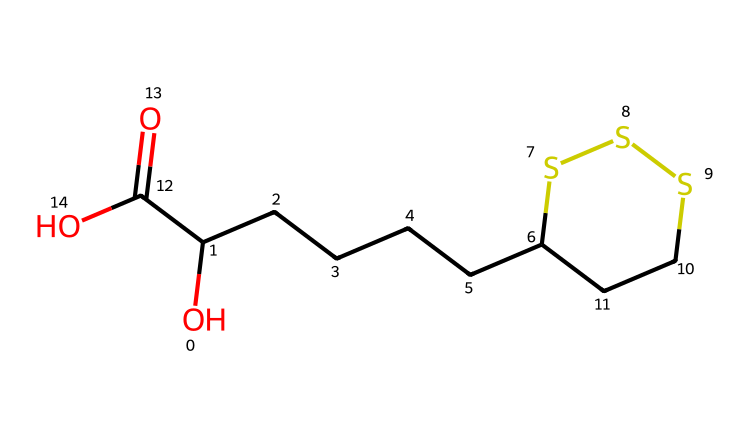What is the molecular formula of alpha-lipoic acid? The molecular formula can be derived from counting the various atoms represented in the SMILES structure. The structure contains 8 carbon (C) atoms, 14 hydrogen (H) atoms, 2 oxygen (O) atoms, and 1 sulfur (S) atom. This leads to the molecular formula C8H14O2S2.
Answer: C8H14O2S2 How many ester functional groups are present in alpha-lipoic acid? By analyzing the structure, we can identify the presence of a carboxylic acid group (C(=O)O) but not an ester functional group, which would require a structure like RCOOR’. Thus, there are no ester groups in alpha-lipoic acid.
Answer: 0 What type of chemical is alpha-lipoic acid classified as? Alpha-lipoic acid is commonly known as a fatty acid, which is indicated by its long carbon chain and carboxylic acid functional group present in the structure. This classification helps identify its functionality in anti-aging skincare.
Answer: fatty acid How many sulfur atoms are present in alpha-lipoic acid? The SMILES representation shows two sulfur (S) atoms present in the structure, indicated by the "SS" in the ring structure. Therefore, it has 2 sulfur atoms.
Answer: 2 Does alpha-lipoic acid contain any double bonds? By closely examining the structure in the SMILES, we can see that the carboxylic acid component has a double bond in the carbonyl (C=O) group, indicating the presence of one double bond in the molecule.
Answer: 1 